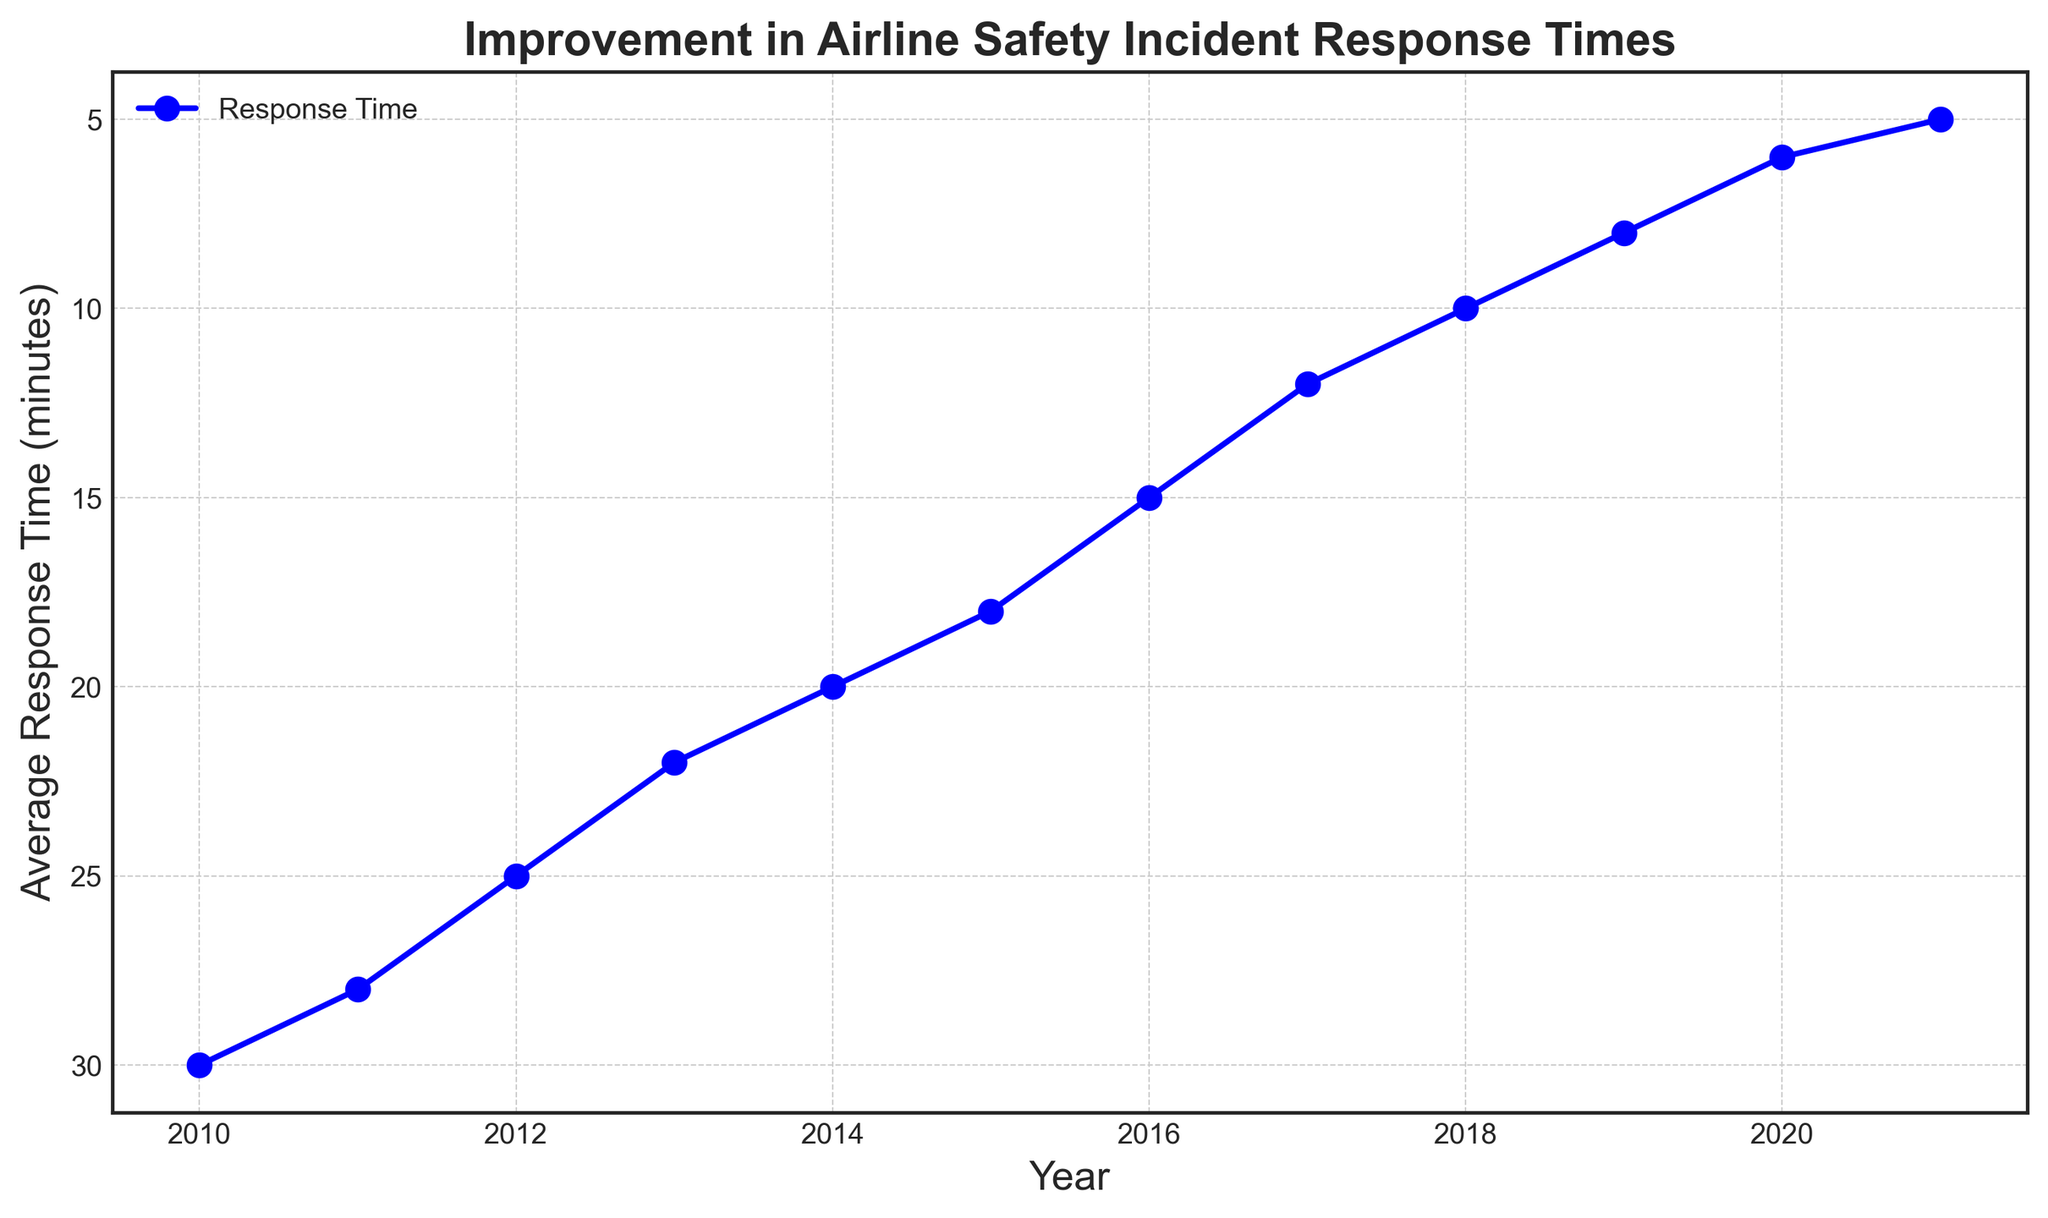What is the average response time in 2018? From the figure, locate the data point for the year 2018 and read the corresponding average response time.
Answer: 10 Which year had the highest average response time? Look at the plot and identify the starting year with the highest response time.
Answer: 2010 By how many minutes did the response time improve from 2010 to 2021? Find the response times for both 2010 and 2021. Subtract the 2021 value from the 2010 value to find the improvement. 30 - 5 = 25.
Answer: 25 What is the trend in the average response time from 2010 to 2021? Observe the direction of the plot's line as it progresses from 2010 to 2021. The line goes downward, indicating a decrease in response times.
Answer: Decreasing What was the response time in 2015, and how did it compare to 2019? Look at the response times for both 2015 and 2019, then compare the two values. 2015: 18, 2019: 8. The response time in 2015 is higher.
Answer: 18, higher Is the decrease in response times linear or irregular from 2010 to 2021? Examine the plot and see if the line forms a straight line (indicating linear) or varies irregularly. The line appears to be nearly straight.
Answer: Nearly linear What is the average response time for the years 2010, 2011, and 2012? Add the response times for these three years (30 + 28 + 25) and divide by 3. (30 + 28 + 25) / 3 = 27.67.
Answer: 27.67 Between which consecutive years was the greatest improvement in response time observed? Look for the largest drop between two consecutive points on the plot. The greatest improvement is between 2016 and 2017 (15 to 12).
Answer: 2016 to 2017 How does the response time trend after 2016 compare to before 2016? Compare the slope and progression of the plot line before and after the year 2016. The response time decreased more sharply after 2016.
Answer: More sharply after 2016 Was there any year where the average response time did not improve? Scan the plot for any flat lines or years where no improvement is observed. All years show an improvement.
Answer: No 